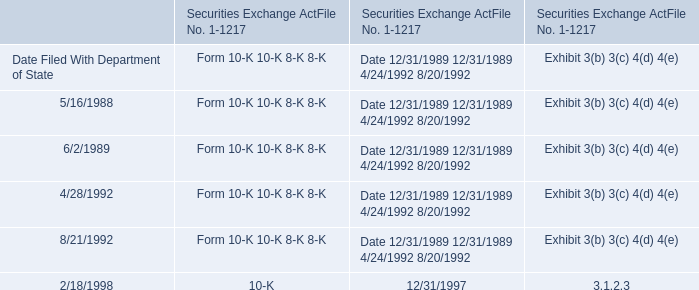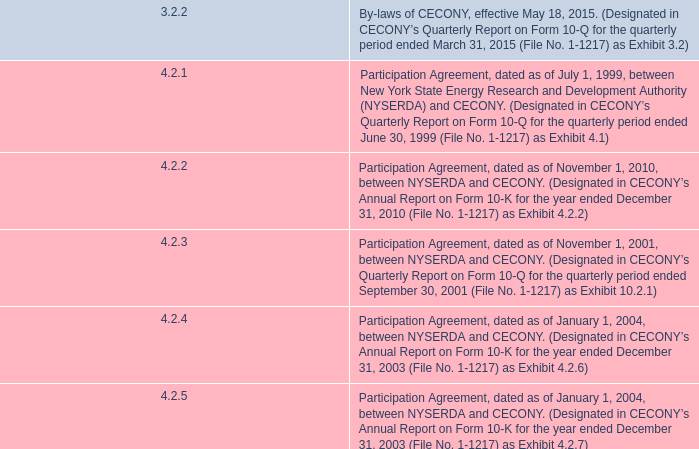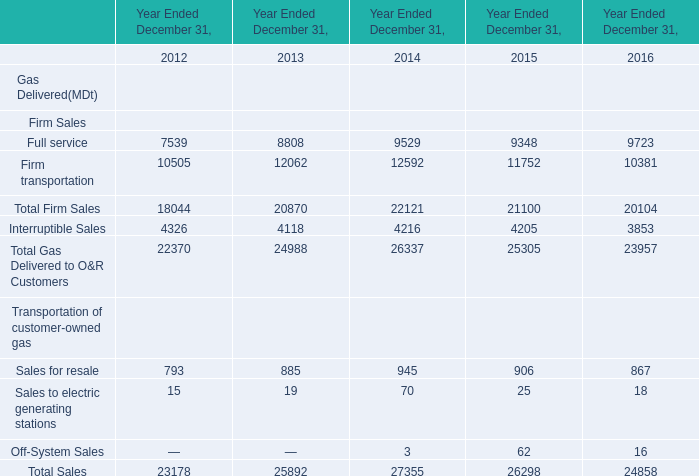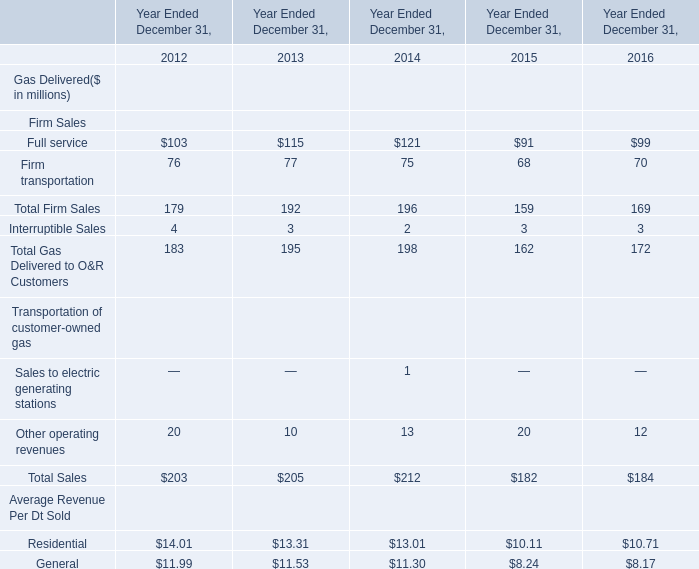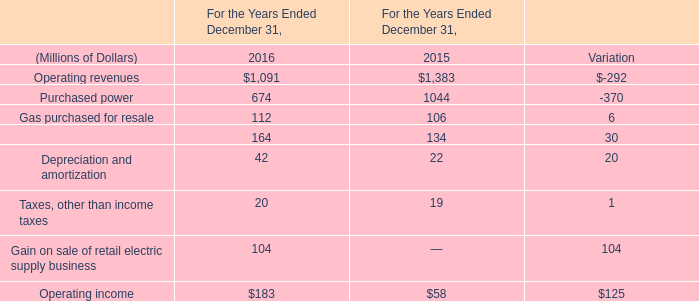What is the average amount of Purchased power of For the Years Ended December 31, 2015, and Full service of Year Ended December 31, 2013 ? 
Computations: ((1044.0 + 8808.0) / 2)
Answer: 4926.0. 